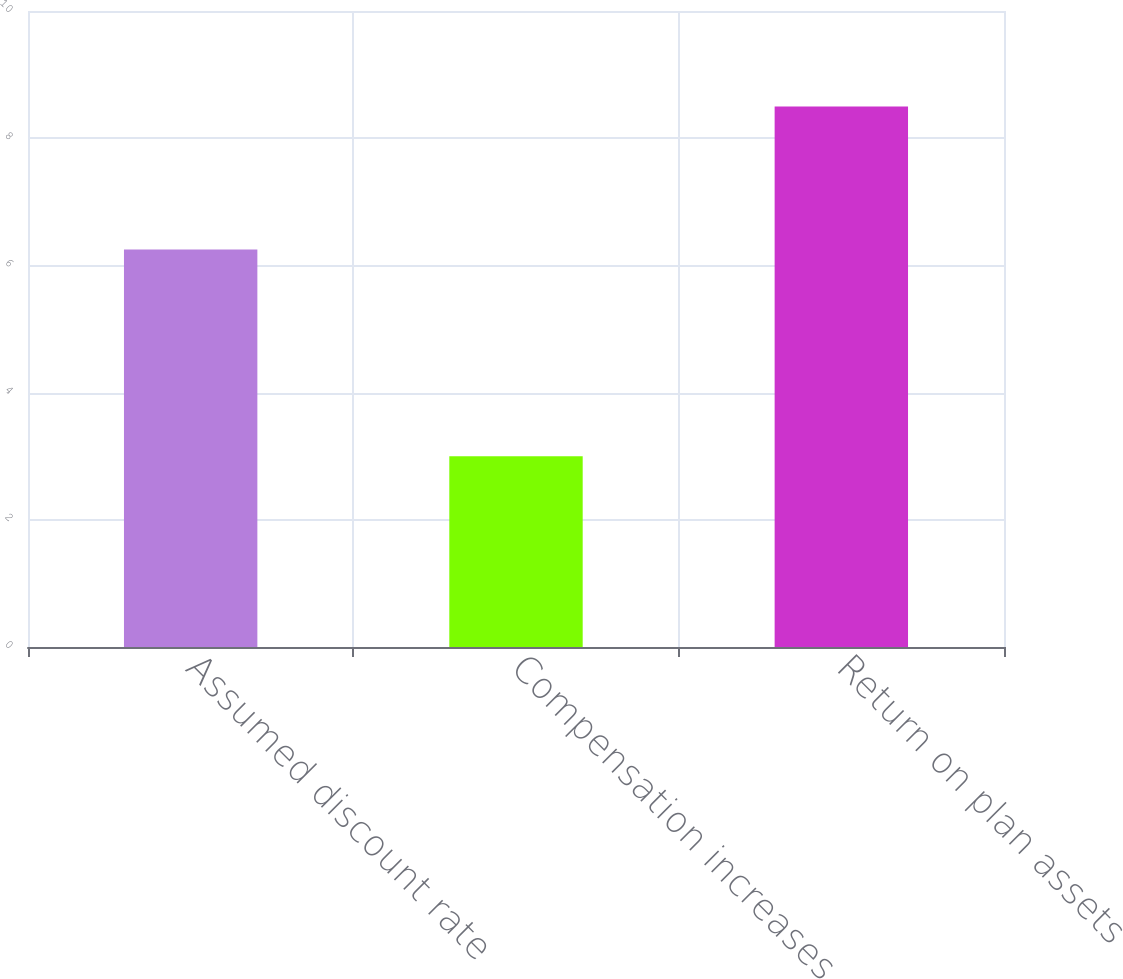<chart> <loc_0><loc_0><loc_500><loc_500><bar_chart><fcel>Assumed discount rate<fcel>Compensation increases<fcel>Return on plan assets<nl><fcel>6.25<fcel>3<fcel>8.5<nl></chart> 